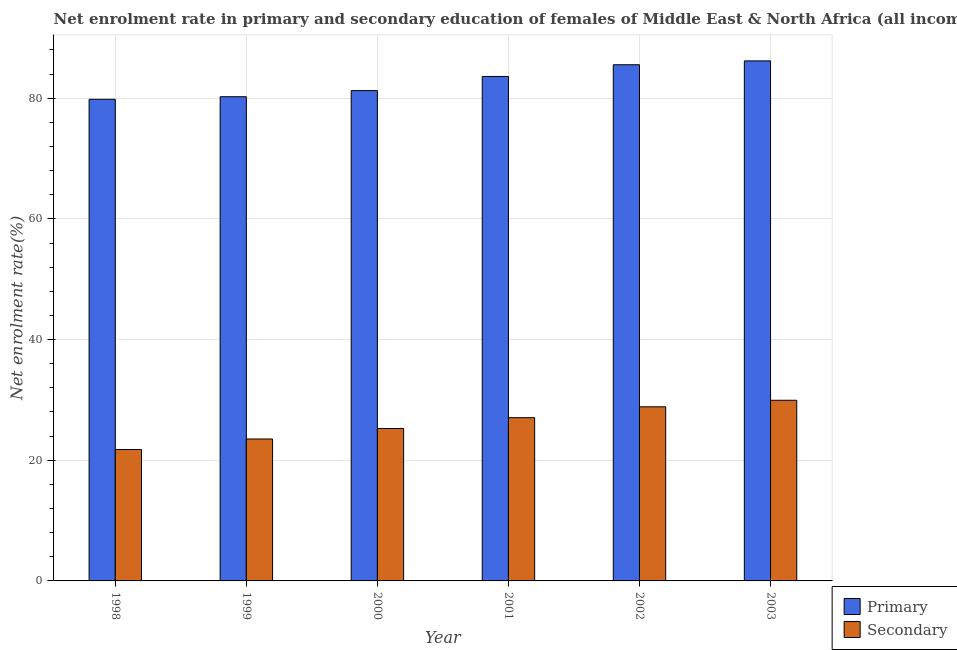How many different coloured bars are there?
Ensure brevity in your answer.  2. Are the number of bars on each tick of the X-axis equal?
Make the answer very short. Yes. How many bars are there on the 2nd tick from the right?
Provide a short and direct response. 2. What is the label of the 4th group of bars from the left?
Keep it short and to the point. 2001. In how many cases, is the number of bars for a given year not equal to the number of legend labels?
Keep it short and to the point. 0. What is the enrollment rate in secondary education in 2003?
Provide a short and direct response. 29.94. Across all years, what is the maximum enrollment rate in primary education?
Give a very brief answer. 86.19. Across all years, what is the minimum enrollment rate in secondary education?
Ensure brevity in your answer.  21.78. What is the total enrollment rate in secondary education in the graph?
Your answer should be compact. 156.42. What is the difference between the enrollment rate in primary education in 2000 and that in 2002?
Your response must be concise. -4.29. What is the difference between the enrollment rate in primary education in 1998 and the enrollment rate in secondary education in 1999?
Offer a terse response. -0.42. What is the average enrollment rate in secondary education per year?
Provide a succinct answer. 26.07. In the year 2002, what is the difference between the enrollment rate in primary education and enrollment rate in secondary education?
Your answer should be very brief. 0. What is the ratio of the enrollment rate in secondary education in 1999 to that in 2002?
Offer a very short reply. 0.82. Is the difference between the enrollment rate in primary education in 2001 and 2002 greater than the difference between the enrollment rate in secondary education in 2001 and 2002?
Your answer should be compact. No. What is the difference between the highest and the second highest enrollment rate in primary education?
Offer a very short reply. 0.64. What is the difference between the highest and the lowest enrollment rate in secondary education?
Your answer should be very brief. 8.16. Is the sum of the enrollment rate in primary education in 1998 and 2002 greater than the maximum enrollment rate in secondary education across all years?
Offer a very short reply. Yes. What does the 1st bar from the left in 2003 represents?
Your response must be concise. Primary. What does the 2nd bar from the right in 1999 represents?
Provide a succinct answer. Primary. How many bars are there?
Your response must be concise. 12. Are all the bars in the graph horizontal?
Ensure brevity in your answer.  No. How many years are there in the graph?
Your answer should be compact. 6. What is the difference between two consecutive major ticks on the Y-axis?
Your answer should be compact. 20. Are the values on the major ticks of Y-axis written in scientific E-notation?
Make the answer very short. No. Does the graph contain any zero values?
Give a very brief answer. No. Where does the legend appear in the graph?
Your answer should be very brief. Bottom right. What is the title of the graph?
Provide a short and direct response. Net enrolment rate in primary and secondary education of females of Middle East & North Africa (all income levels). Does "Highest 10% of population" appear as one of the legend labels in the graph?
Offer a very short reply. No. What is the label or title of the X-axis?
Offer a very short reply. Year. What is the label or title of the Y-axis?
Offer a very short reply. Net enrolment rate(%). What is the Net enrolment rate(%) of Primary in 1998?
Provide a short and direct response. 79.83. What is the Net enrolment rate(%) in Secondary in 1998?
Give a very brief answer. 21.78. What is the Net enrolment rate(%) of Primary in 1999?
Ensure brevity in your answer.  80.25. What is the Net enrolment rate(%) in Secondary in 1999?
Ensure brevity in your answer.  23.53. What is the Net enrolment rate(%) in Primary in 2000?
Keep it short and to the point. 81.26. What is the Net enrolment rate(%) of Secondary in 2000?
Make the answer very short. 25.26. What is the Net enrolment rate(%) of Primary in 2001?
Offer a terse response. 83.61. What is the Net enrolment rate(%) of Secondary in 2001?
Make the answer very short. 27.06. What is the Net enrolment rate(%) of Primary in 2002?
Your response must be concise. 85.55. What is the Net enrolment rate(%) in Secondary in 2002?
Provide a short and direct response. 28.86. What is the Net enrolment rate(%) in Primary in 2003?
Offer a very short reply. 86.19. What is the Net enrolment rate(%) in Secondary in 2003?
Provide a short and direct response. 29.94. Across all years, what is the maximum Net enrolment rate(%) in Primary?
Offer a very short reply. 86.19. Across all years, what is the maximum Net enrolment rate(%) in Secondary?
Your answer should be very brief. 29.94. Across all years, what is the minimum Net enrolment rate(%) in Primary?
Your response must be concise. 79.83. Across all years, what is the minimum Net enrolment rate(%) in Secondary?
Your response must be concise. 21.78. What is the total Net enrolment rate(%) in Primary in the graph?
Your answer should be compact. 496.69. What is the total Net enrolment rate(%) of Secondary in the graph?
Provide a short and direct response. 156.42. What is the difference between the Net enrolment rate(%) of Primary in 1998 and that in 1999?
Your answer should be very brief. -0.42. What is the difference between the Net enrolment rate(%) of Secondary in 1998 and that in 1999?
Give a very brief answer. -1.75. What is the difference between the Net enrolment rate(%) of Primary in 1998 and that in 2000?
Make the answer very short. -1.43. What is the difference between the Net enrolment rate(%) of Secondary in 1998 and that in 2000?
Keep it short and to the point. -3.48. What is the difference between the Net enrolment rate(%) of Primary in 1998 and that in 2001?
Your response must be concise. -3.78. What is the difference between the Net enrolment rate(%) of Secondary in 1998 and that in 2001?
Offer a very short reply. -5.28. What is the difference between the Net enrolment rate(%) of Primary in 1998 and that in 2002?
Keep it short and to the point. -5.73. What is the difference between the Net enrolment rate(%) of Secondary in 1998 and that in 2002?
Offer a terse response. -7.08. What is the difference between the Net enrolment rate(%) of Primary in 1998 and that in 2003?
Keep it short and to the point. -6.37. What is the difference between the Net enrolment rate(%) in Secondary in 1998 and that in 2003?
Provide a succinct answer. -8.16. What is the difference between the Net enrolment rate(%) of Primary in 1999 and that in 2000?
Your answer should be compact. -1.01. What is the difference between the Net enrolment rate(%) in Secondary in 1999 and that in 2000?
Provide a succinct answer. -1.74. What is the difference between the Net enrolment rate(%) of Primary in 1999 and that in 2001?
Your response must be concise. -3.36. What is the difference between the Net enrolment rate(%) in Secondary in 1999 and that in 2001?
Your answer should be very brief. -3.53. What is the difference between the Net enrolment rate(%) of Primary in 1999 and that in 2002?
Offer a very short reply. -5.3. What is the difference between the Net enrolment rate(%) of Secondary in 1999 and that in 2002?
Give a very brief answer. -5.33. What is the difference between the Net enrolment rate(%) in Primary in 1999 and that in 2003?
Your answer should be compact. -5.94. What is the difference between the Net enrolment rate(%) in Secondary in 1999 and that in 2003?
Make the answer very short. -6.42. What is the difference between the Net enrolment rate(%) in Primary in 2000 and that in 2001?
Your answer should be very brief. -2.35. What is the difference between the Net enrolment rate(%) in Secondary in 2000 and that in 2001?
Provide a succinct answer. -1.79. What is the difference between the Net enrolment rate(%) of Primary in 2000 and that in 2002?
Provide a short and direct response. -4.29. What is the difference between the Net enrolment rate(%) of Secondary in 2000 and that in 2002?
Provide a succinct answer. -3.6. What is the difference between the Net enrolment rate(%) of Primary in 2000 and that in 2003?
Make the answer very short. -4.93. What is the difference between the Net enrolment rate(%) of Secondary in 2000 and that in 2003?
Ensure brevity in your answer.  -4.68. What is the difference between the Net enrolment rate(%) in Primary in 2001 and that in 2002?
Provide a succinct answer. -1.94. What is the difference between the Net enrolment rate(%) of Secondary in 2001 and that in 2002?
Make the answer very short. -1.8. What is the difference between the Net enrolment rate(%) of Primary in 2001 and that in 2003?
Provide a succinct answer. -2.58. What is the difference between the Net enrolment rate(%) of Secondary in 2001 and that in 2003?
Your response must be concise. -2.88. What is the difference between the Net enrolment rate(%) of Primary in 2002 and that in 2003?
Provide a short and direct response. -0.64. What is the difference between the Net enrolment rate(%) of Secondary in 2002 and that in 2003?
Give a very brief answer. -1.08. What is the difference between the Net enrolment rate(%) of Primary in 1998 and the Net enrolment rate(%) of Secondary in 1999?
Make the answer very short. 56.3. What is the difference between the Net enrolment rate(%) of Primary in 1998 and the Net enrolment rate(%) of Secondary in 2000?
Your answer should be compact. 54.56. What is the difference between the Net enrolment rate(%) of Primary in 1998 and the Net enrolment rate(%) of Secondary in 2001?
Offer a very short reply. 52.77. What is the difference between the Net enrolment rate(%) of Primary in 1998 and the Net enrolment rate(%) of Secondary in 2002?
Your answer should be compact. 50.97. What is the difference between the Net enrolment rate(%) in Primary in 1998 and the Net enrolment rate(%) in Secondary in 2003?
Offer a very short reply. 49.89. What is the difference between the Net enrolment rate(%) in Primary in 1999 and the Net enrolment rate(%) in Secondary in 2000?
Make the answer very short. 54.99. What is the difference between the Net enrolment rate(%) of Primary in 1999 and the Net enrolment rate(%) of Secondary in 2001?
Your answer should be very brief. 53.2. What is the difference between the Net enrolment rate(%) of Primary in 1999 and the Net enrolment rate(%) of Secondary in 2002?
Offer a very short reply. 51.39. What is the difference between the Net enrolment rate(%) of Primary in 1999 and the Net enrolment rate(%) of Secondary in 2003?
Ensure brevity in your answer.  50.31. What is the difference between the Net enrolment rate(%) in Primary in 2000 and the Net enrolment rate(%) in Secondary in 2001?
Make the answer very short. 54.2. What is the difference between the Net enrolment rate(%) of Primary in 2000 and the Net enrolment rate(%) of Secondary in 2002?
Your answer should be very brief. 52.4. What is the difference between the Net enrolment rate(%) of Primary in 2000 and the Net enrolment rate(%) of Secondary in 2003?
Your answer should be compact. 51.32. What is the difference between the Net enrolment rate(%) in Primary in 2001 and the Net enrolment rate(%) in Secondary in 2002?
Provide a short and direct response. 54.75. What is the difference between the Net enrolment rate(%) in Primary in 2001 and the Net enrolment rate(%) in Secondary in 2003?
Provide a short and direct response. 53.67. What is the difference between the Net enrolment rate(%) in Primary in 2002 and the Net enrolment rate(%) in Secondary in 2003?
Provide a succinct answer. 55.61. What is the average Net enrolment rate(%) in Primary per year?
Offer a terse response. 82.78. What is the average Net enrolment rate(%) of Secondary per year?
Provide a succinct answer. 26.07. In the year 1998, what is the difference between the Net enrolment rate(%) of Primary and Net enrolment rate(%) of Secondary?
Your answer should be very brief. 58.05. In the year 1999, what is the difference between the Net enrolment rate(%) in Primary and Net enrolment rate(%) in Secondary?
Ensure brevity in your answer.  56.73. In the year 2000, what is the difference between the Net enrolment rate(%) in Primary and Net enrolment rate(%) in Secondary?
Give a very brief answer. 56. In the year 2001, what is the difference between the Net enrolment rate(%) in Primary and Net enrolment rate(%) in Secondary?
Offer a terse response. 56.55. In the year 2002, what is the difference between the Net enrolment rate(%) in Primary and Net enrolment rate(%) in Secondary?
Your answer should be very brief. 56.69. In the year 2003, what is the difference between the Net enrolment rate(%) in Primary and Net enrolment rate(%) in Secondary?
Offer a very short reply. 56.25. What is the ratio of the Net enrolment rate(%) of Primary in 1998 to that in 1999?
Make the answer very short. 0.99. What is the ratio of the Net enrolment rate(%) in Secondary in 1998 to that in 1999?
Provide a succinct answer. 0.93. What is the ratio of the Net enrolment rate(%) of Primary in 1998 to that in 2000?
Offer a terse response. 0.98. What is the ratio of the Net enrolment rate(%) of Secondary in 1998 to that in 2000?
Offer a terse response. 0.86. What is the ratio of the Net enrolment rate(%) in Primary in 1998 to that in 2001?
Ensure brevity in your answer.  0.95. What is the ratio of the Net enrolment rate(%) of Secondary in 1998 to that in 2001?
Give a very brief answer. 0.81. What is the ratio of the Net enrolment rate(%) of Primary in 1998 to that in 2002?
Make the answer very short. 0.93. What is the ratio of the Net enrolment rate(%) of Secondary in 1998 to that in 2002?
Offer a terse response. 0.75. What is the ratio of the Net enrolment rate(%) in Primary in 1998 to that in 2003?
Offer a very short reply. 0.93. What is the ratio of the Net enrolment rate(%) in Secondary in 1998 to that in 2003?
Provide a short and direct response. 0.73. What is the ratio of the Net enrolment rate(%) of Primary in 1999 to that in 2000?
Your answer should be very brief. 0.99. What is the ratio of the Net enrolment rate(%) in Secondary in 1999 to that in 2000?
Make the answer very short. 0.93. What is the ratio of the Net enrolment rate(%) in Primary in 1999 to that in 2001?
Keep it short and to the point. 0.96. What is the ratio of the Net enrolment rate(%) in Secondary in 1999 to that in 2001?
Your answer should be very brief. 0.87. What is the ratio of the Net enrolment rate(%) in Primary in 1999 to that in 2002?
Your answer should be compact. 0.94. What is the ratio of the Net enrolment rate(%) of Secondary in 1999 to that in 2002?
Give a very brief answer. 0.82. What is the ratio of the Net enrolment rate(%) of Primary in 1999 to that in 2003?
Provide a short and direct response. 0.93. What is the ratio of the Net enrolment rate(%) in Secondary in 1999 to that in 2003?
Offer a very short reply. 0.79. What is the ratio of the Net enrolment rate(%) in Primary in 2000 to that in 2001?
Provide a short and direct response. 0.97. What is the ratio of the Net enrolment rate(%) in Secondary in 2000 to that in 2001?
Offer a terse response. 0.93. What is the ratio of the Net enrolment rate(%) of Primary in 2000 to that in 2002?
Provide a succinct answer. 0.95. What is the ratio of the Net enrolment rate(%) in Secondary in 2000 to that in 2002?
Provide a short and direct response. 0.88. What is the ratio of the Net enrolment rate(%) in Primary in 2000 to that in 2003?
Your response must be concise. 0.94. What is the ratio of the Net enrolment rate(%) of Secondary in 2000 to that in 2003?
Give a very brief answer. 0.84. What is the ratio of the Net enrolment rate(%) of Primary in 2001 to that in 2002?
Your response must be concise. 0.98. What is the ratio of the Net enrolment rate(%) of Secondary in 2001 to that in 2003?
Make the answer very short. 0.9. What is the ratio of the Net enrolment rate(%) in Secondary in 2002 to that in 2003?
Keep it short and to the point. 0.96. What is the difference between the highest and the second highest Net enrolment rate(%) in Primary?
Your response must be concise. 0.64. What is the difference between the highest and the second highest Net enrolment rate(%) of Secondary?
Provide a short and direct response. 1.08. What is the difference between the highest and the lowest Net enrolment rate(%) in Primary?
Keep it short and to the point. 6.37. What is the difference between the highest and the lowest Net enrolment rate(%) of Secondary?
Provide a short and direct response. 8.16. 